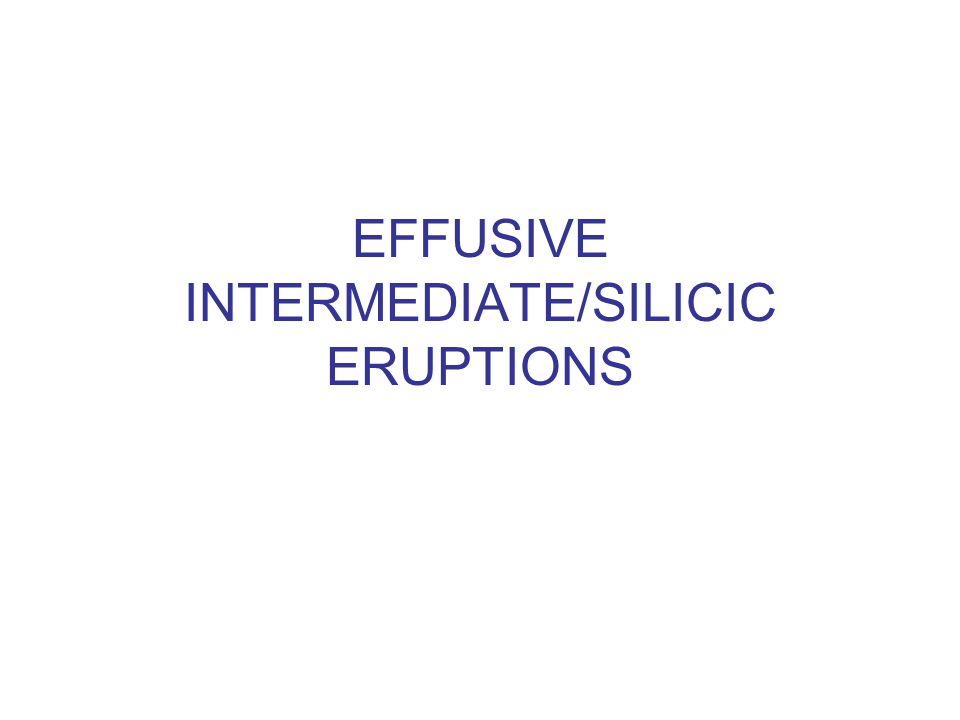Could the text refer to a classification within a scientific field, and if so, what field might that be? Yes, the text certainly refers to a classification within the scientific field of geology, specifically in the area of volcanology. It presents terms like 'effusive', 'intermediate', and 'silicic', all of which are pivotal in categorizing various types of volcanic eruptions. 'Effusive' eruptions are characterized by the gentle flow of lava out of a volcano, whereas terms like 'intermediate' and 'silicic' pertain to the silica content in volcanic rocks which influences the viscosity and the explosiveness of eruptions. This kind of classification helps scientists predict volcanic behavior and devise appropriate safety measures. 